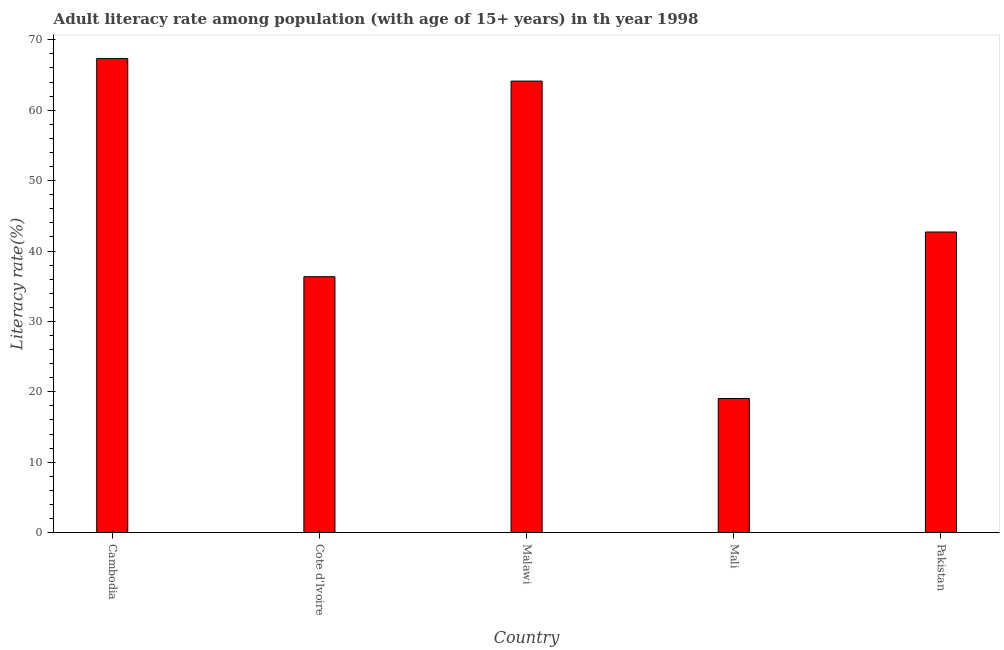Does the graph contain any zero values?
Provide a short and direct response. No. Does the graph contain grids?
Give a very brief answer. No. What is the title of the graph?
Give a very brief answer. Adult literacy rate among population (with age of 15+ years) in th year 1998. What is the label or title of the Y-axis?
Give a very brief answer. Literacy rate(%). What is the adult literacy rate in Mali?
Offer a very short reply. 19.04. Across all countries, what is the maximum adult literacy rate?
Your response must be concise. 67.34. Across all countries, what is the minimum adult literacy rate?
Provide a short and direct response. 19.04. In which country was the adult literacy rate maximum?
Offer a terse response. Cambodia. In which country was the adult literacy rate minimum?
Your response must be concise. Mali. What is the sum of the adult literacy rate?
Provide a short and direct response. 229.56. What is the difference between the adult literacy rate in Cote d'Ivoire and Malawi?
Give a very brief answer. -27.78. What is the average adult literacy rate per country?
Your answer should be compact. 45.91. What is the median adult literacy rate?
Your answer should be very brief. 42.7. What is the ratio of the adult literacy rate in Cote d'Ivoire to that in Mali?
Ensure brevity in your answer.  1.91. Is the difference between the adult literacy rate in Cote d'Ivoire and Pakistan greater than the difference between any two countries?
Keep it short and to the point. No. What is the difference between the highest and the second highest adult literacy rate?
Provide a short and direct response. 3.2. Is the sum of the adult literacy rate in Cambodia and Cote d'Ivoire greater than the maximum adult literacy rate across all countries?
Provide a succinct answer. Yes. What is the difference between the highest and the lowest adult literacy rate?
Provide a succinct answer. 48.29. In how many countries, is the adult literacy rate greater than the average adult literacy rate taken over all countries?
Your answer should be very brief. 2. How many bars are there?
Make the answer very short. 5. Are all the bars in the graph horizontal?
Offer a terse response. No. What is the Literacy rate(%) of Cambodia?
Your answer should be very brief. 67.34. What is the Literacy rate(%) in Cote d'Ivoire?
Ensure brevity in your answer.  36.35. What is the Literacy rate(%) of Malawi?
Offer a terse response. 64.13. What is the Literacy rate(%) in Mali?
Offer a terse response. 19.04. What is the Literacy rate(%) in Pakistan?
Provide a succinct answer. 42.7. What is the difference between the Literacy rate(%) in Cambodia and Cote d'Ivoire?
Keep it short and to the point. 30.98. What is the difference between the Literacy rate(%) in Cambodia and Malawi?
Offer a terse response. 3.2. What is the difference between the Literacy rate(%) in Cambodia and Mali?
Your answer should be very brief. 48.29. What is the difference between the Literacy rate(%) in Cambodia and Pakistan?
Offer a very short reply. 24.64. What is the difference between the Literacy rate(%) in Cote d'Ivoire and Malawi?
Offer a terse response. -27.78. What is the difference between the Literacy rate(%) in Cote d'Ivoire and Mali?
Keep it short and to the point. 17.31. What is the difference between the Literacy rate(%) in Cote d'Ivoire and Pakistan?
Offer a very short reply. -6.35. What is the difference between the Literacy rate(%) in Malawi and Mali?
Ensure brevity in your answer.  45.09. What is the difference between the Literacy rate(%) in Malawi and Pakistan?
Your answer should be very brief. 21.43. What is the difference between the Literacy rate(%) in Mali and Pakistan?
Ensure brevity in your answer.  -23.65. What is the ratio of the Literacy rate(%) in Cambodia to that in Cote d'Ivoire?
Provide a succinct answer. 1.85. What is the ratio of the Literacy rate(%) in Cambodia to that in Malawi?
Offer a very short reply. 1.05. What is the ratio of the Literacy rate(%) in Cambodia to that in Mali?
Provide a short and direct response. 3.54. What is the ratio of the Literacy rate(%) in Cambodia to that in Pakistan?
Provide a succinct answer. 1.58. What is the ratio of the Literacy rate(%) in Cote d'Ivoire to that in Malawi?
Offer a very short reply. 0.57. What is the ratio of the Literacy rate(%) in Cote d'Ivoire to that in Mali?
Make the answer very short. 1.91. What is the ratio of the Literacy rate(%) in Cote d'Ivoire to that in Pakistan?
Provide a succinct answer. 0.85. What is the ratio of the Literacy rate(%) in Malawi to that in Mali?
Offer a terse response. 3.37. What is the ratio of the Literacy rate(%) in Malawi to that in Pakistan?
Offer a terse response. 1.5. What is the ratio of the Literacy rate(%) in Mali to that in Pakistan?
Your response must be concise. 0.45. 